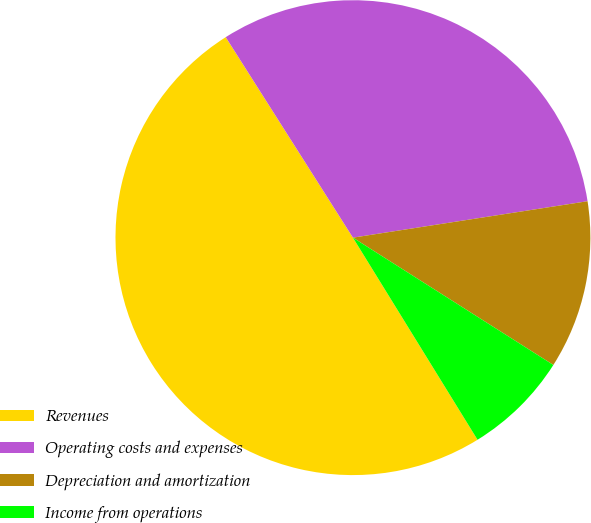Convert chart to OTSL. <chart><loc_0><loc_0><loc_500><loc_500><pie_chart><fcel>Revenues<fcel>Operating costs and expenses<fcel>Depreciation and amortization<fcel>Income from operations<nl><fcel>49.8%<fcel>31.55%<fcel>11.46%<fcel>7.2%<nl></chart> 